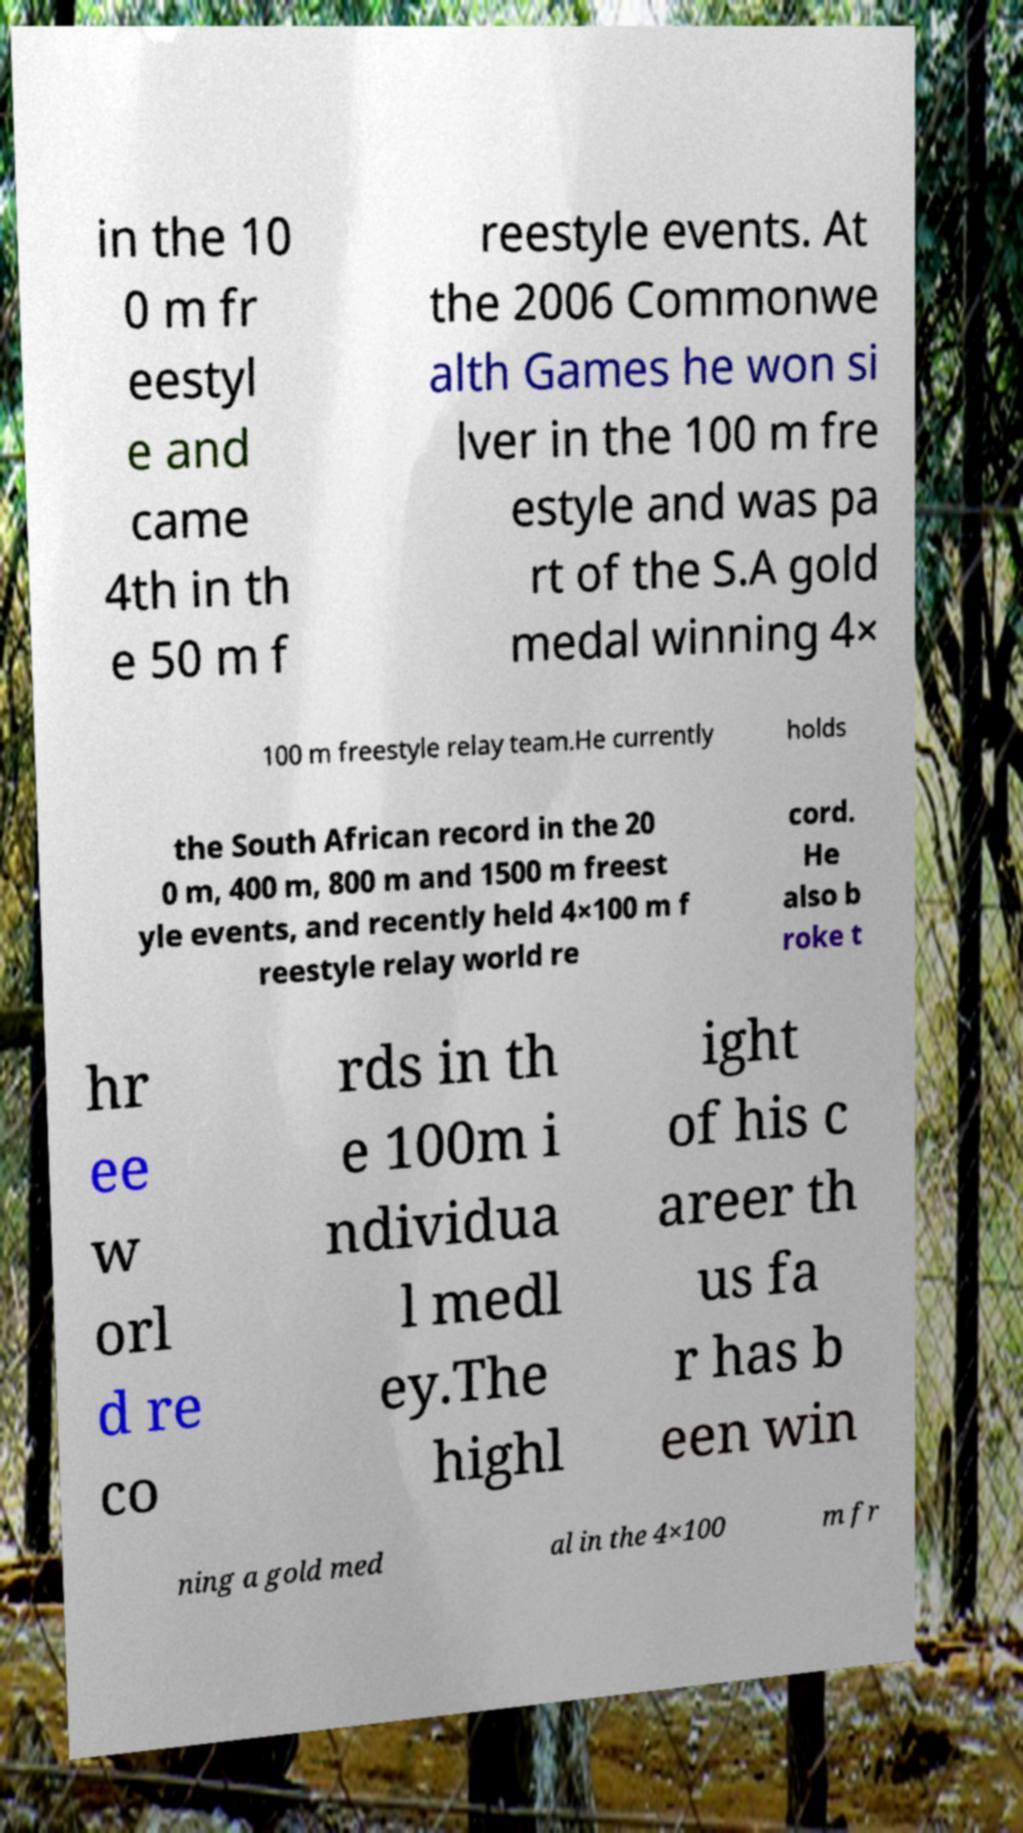Could you assist in decoding the text presented in this image and type it out clearly? in the 10 0 m fr eestyl e and came 4th in th e 50 m f reestyle events. At the 2006 Commonwe alth Games he won si lver in the 100 m fre estyle and was pa rt of the S.A gold medal winning 4× 100 m freestyle relay team.He currently holds the South African record in the 20 0 m, 400 m, 800 m and 1500 m freest yle events, and recently held 4×100 m f reestyle relay world re cord. He also b roke t hr ee w orl d re co rds in th e 100m i ndividua l medl ey.The highl ight of his c areer th us fa r has b een win ning a gold med al in the 4×100 m fr 